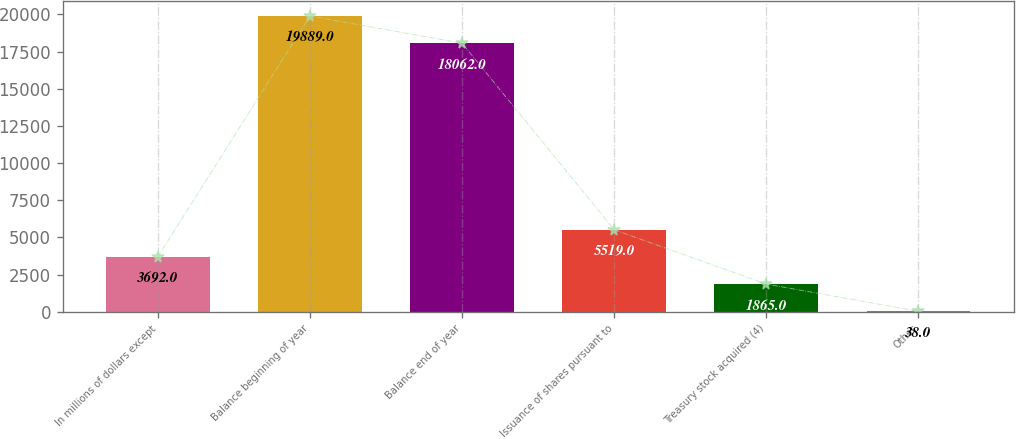Convert chart. <chart><loc_0><loc_0><loc_500><loc_500><bar_chart><fcel>In millions of dollars except<fcel>Balance beginning of year<fcel>Balance end of year<fcel>Issuance of shares pursuant to<fcel>Treasury stock acquired (4)<fcel>Other<nl><fcel>3692<fcel>19889<fcel>18062<fcel>5519<fcel>1865<fcel>38<nl></chart> 